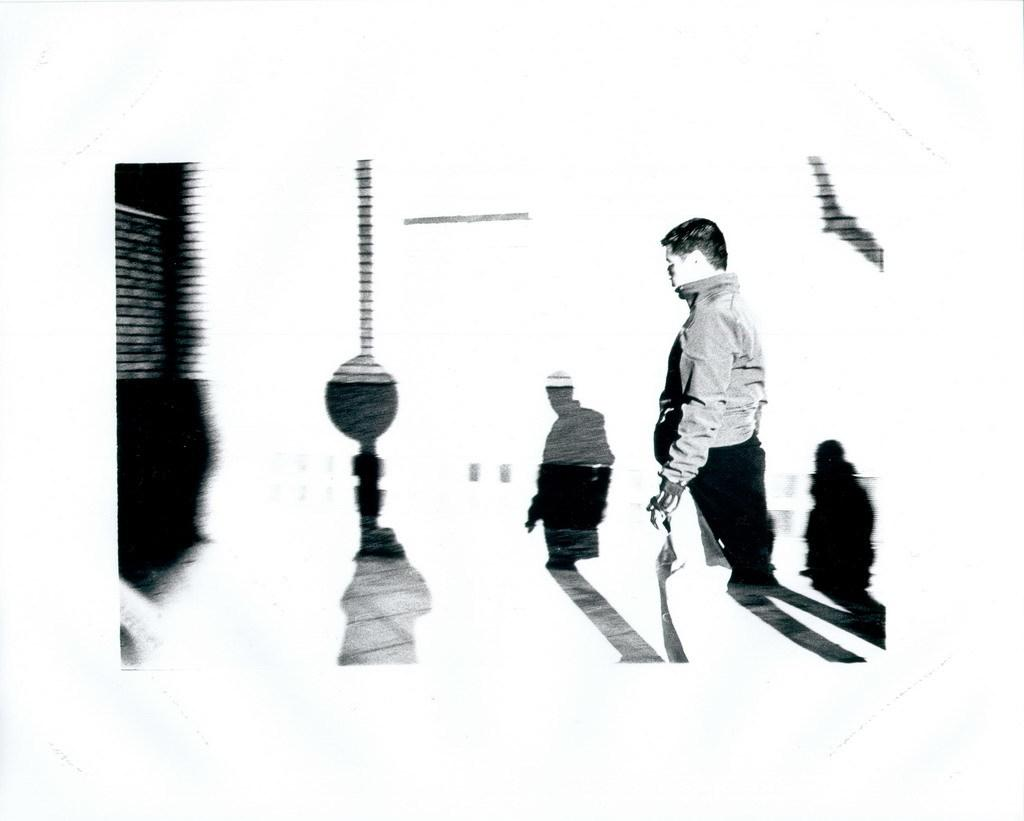What is the color scheme of the image? The image is black and white. Where is the man located in the image? The man is standing on the right side of the image. What is behind the man in the image? The man is standing in front of a wall. What can be seen on the wall in the background? There are shadows of persons and a pillar on the background wall. What type of canvas is the man painting in the image? There is no canvas or painting activity present in the image. Can you tell me what kind of soup the man is holding in the image? There is no soup or any food item visible in the image. 